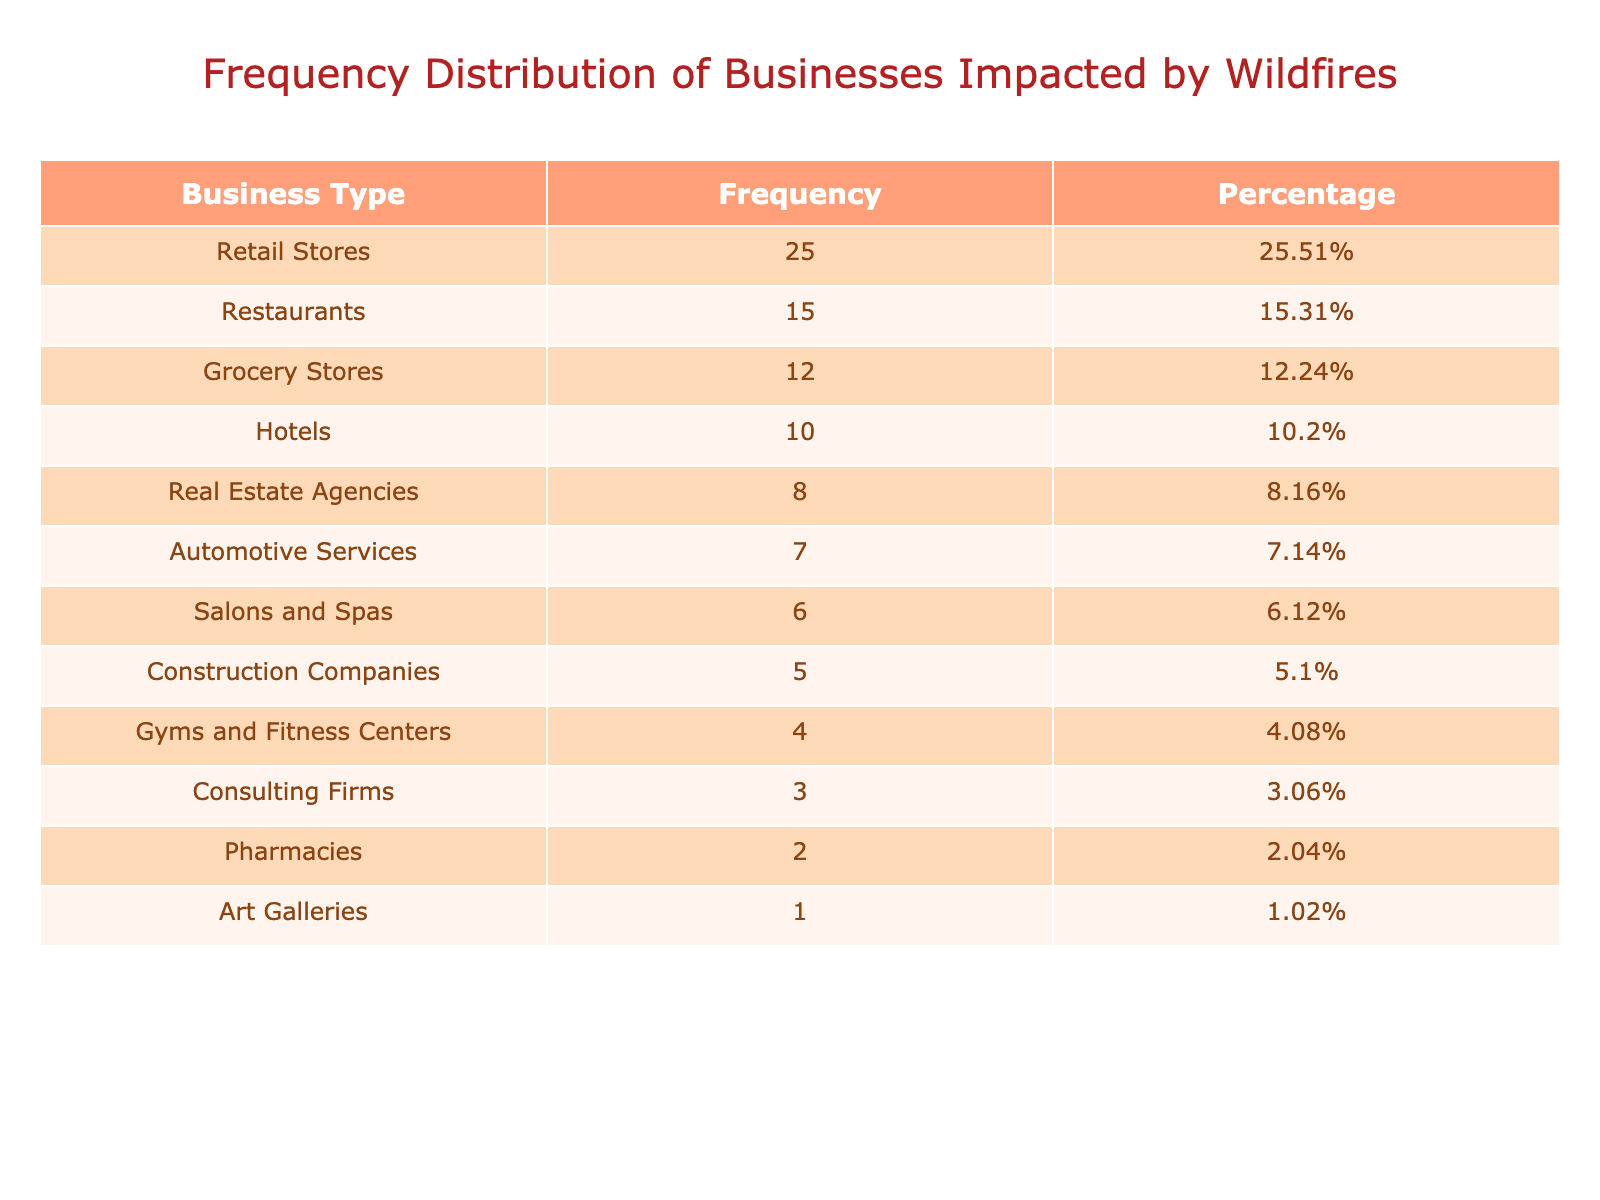What is the total number of businesses impacted by the wildfires? To find the total number of businesses impacted, I need to sum the "Number of Businesses Impacted" for all business types listed in the table. The sum is 15 + 25 + 10 + 5 + 8 + 12 + 6 + 4 + 2 + 3 + 7 + 1 = 93.
Answer: 93 Which business type has the highest number of businesses impacted? Referring to the "Frequency" column, Retail Stores have the highest number with 25 businesses impacted, which is greater than the frequencies of the other business types.
Answer: Retail Stores How many more restaurants were impacted than automotive services? To find the difference, I will subtract the number of automotive services impacted (7) from the number of restaurants impacted (15). The calculation is 15 - 7 = 8.
Answer: 8 Is it true that fewer than 5 gyms and fitness centers were impacted by the wildfires? The table indicates that 4 gyms and fitness centers were impacted, which is indeed fewer than 5; thus, the statement is true.
Answer: Yes What percentage of impacted businesses are restaurants? To find the percentage of impacted businesses that are restaurants, I will divide the number of impacted restaurants (15) by the total number of impacted businesses (93) and multiply by 100. The calculation is (15/93) * 100 ≈ 16.13%.
Answer: 16.13% How many business types had more than 10 businesses impacted? By examining the "Frequency" column, I can identify that there are three business types with more than 10 impacted: Restaurants (15), Retail Stores (25), and Grocery Stores (12).
Answer: 3 What is the average number of businesses impacted across all types? To find the average, I will first sum the number of businesses impacted (93) and then divide by the number of business types (12). The average is 93 / 12 ≈ 7.75.
Answer: 7.75 Which business type has the least impact from the wildfires? Looking at the "Frequency" column, Art Galleries have the least number impacted with only 1 business affected, which is lower than any other business type listed.
Answer: Art Galleries 